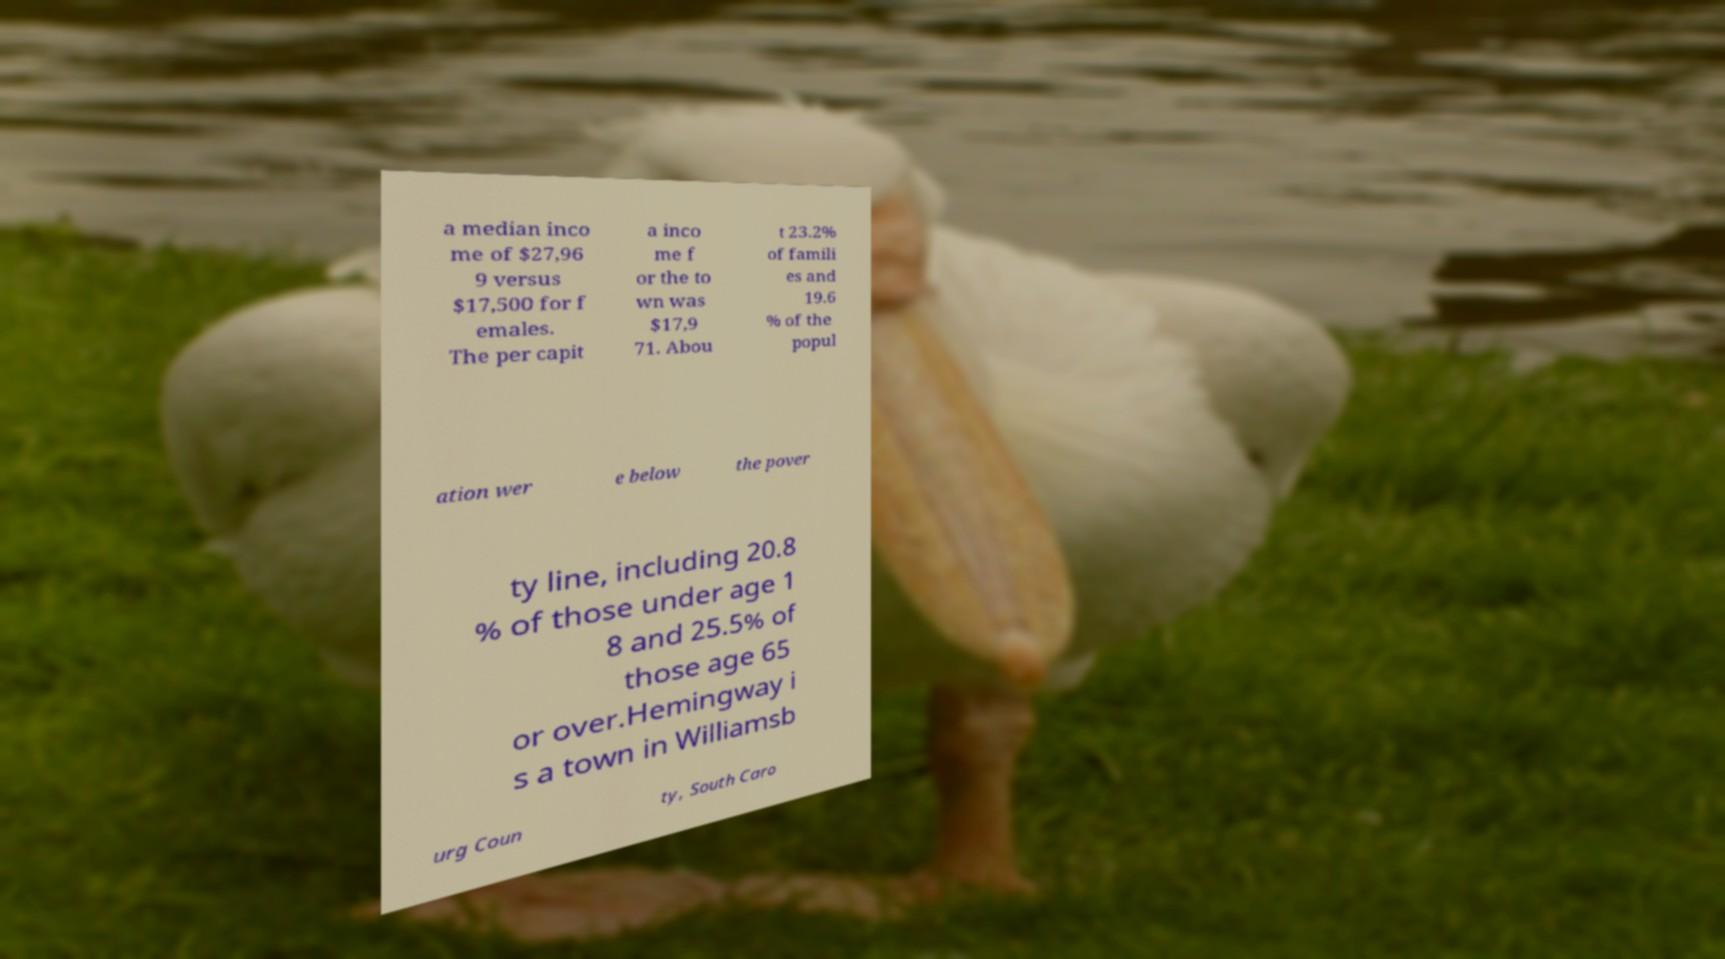For documentation purposes, I need the text within this image transcribed. Could you provide that? a median inco me of $27,96 9 versus $17,500 for f emales. The per capit a inco me f or the to wn was $17,9 71. Abou t 23.2% of famili es and 19.6 % of the popul ation wer e below the pover ty line, including 20.8 % of those under age 1 8 and 25.5% of those age 65 or over.Hemingway i s a town in Williamsb urg Coun ty, South Caro 